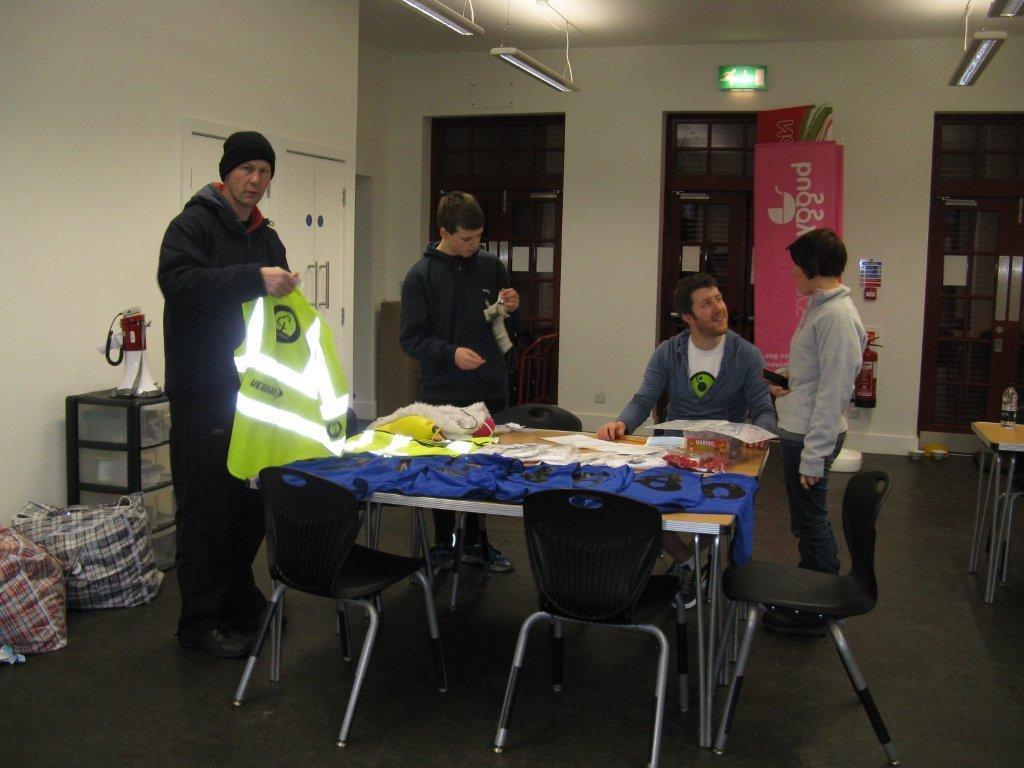Please provide a concise description of this image. in this image I can see four persons, three are standing and one is sitting. Two people are black jackets and one wearing blue jacket. The person from the left side is wearing a black color cap. on the left side of this image I can see two bags on the floor. Beside these bags there is a table. In the center of this image there is a table and having some chairs around it. I can see some clothes on the table. In the background there is a white color wall and there are two windows. On the top there is a light. 